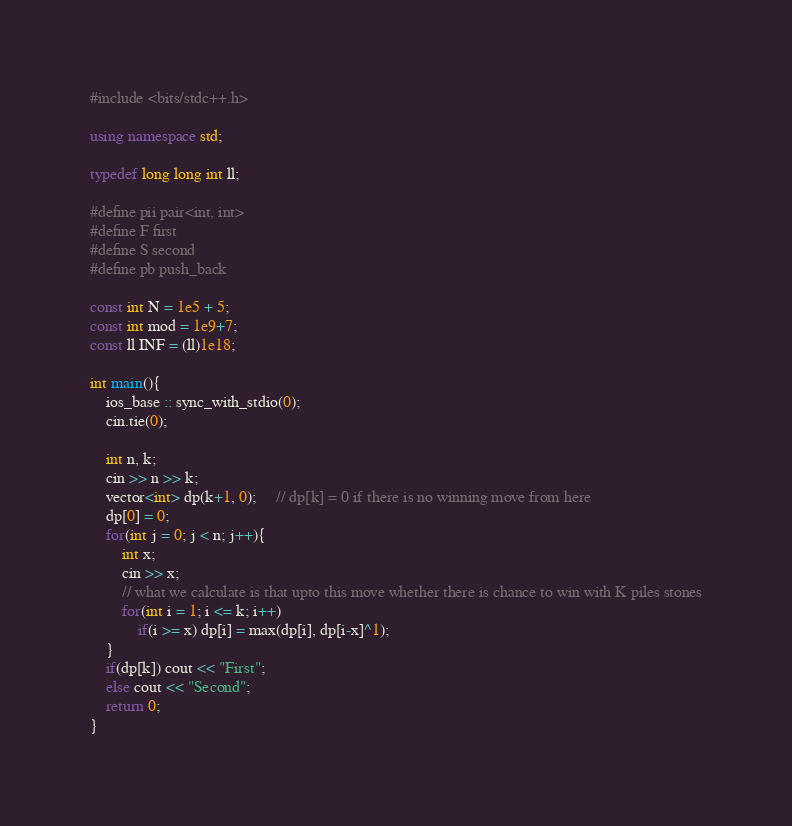Convert code to text. <code><loc_0><loc_0><loc_500><loc_500><_C++_>#include <bits/stdc++.h>
 
using namespace std;
 
typedef long long int ll;
 
#define pii pair<int, int>
#define F first
#define S second
#define pb push_back
 
const int N = 1e5 + 5;
const int mod = 1e9+7;
const ll INF = (ll)1e18;

int main(){
    ios_base :: sync_with_stdio(0);
    cin.tie(0);
 
    int n, k;
    cin >> n >> k;
    vector<int> dp(k+1, 0);     // dp[k] = 0 if there is no winning move from here
    dp[0] = 0;
    for(int j = 0; j < n; j++){
        int x;
        cin >> x;
        // what we calculate is that upto this move whether there is chance to win with K piles stones
        for(int i = 1; i <= k; i++)
            if(i >= x) dp[i] = max(dp[i], dp[i-x]^1);
    }
    if(dp[k]) cout << "First";
    else cout << "Second";
    return 0;
}</code> 